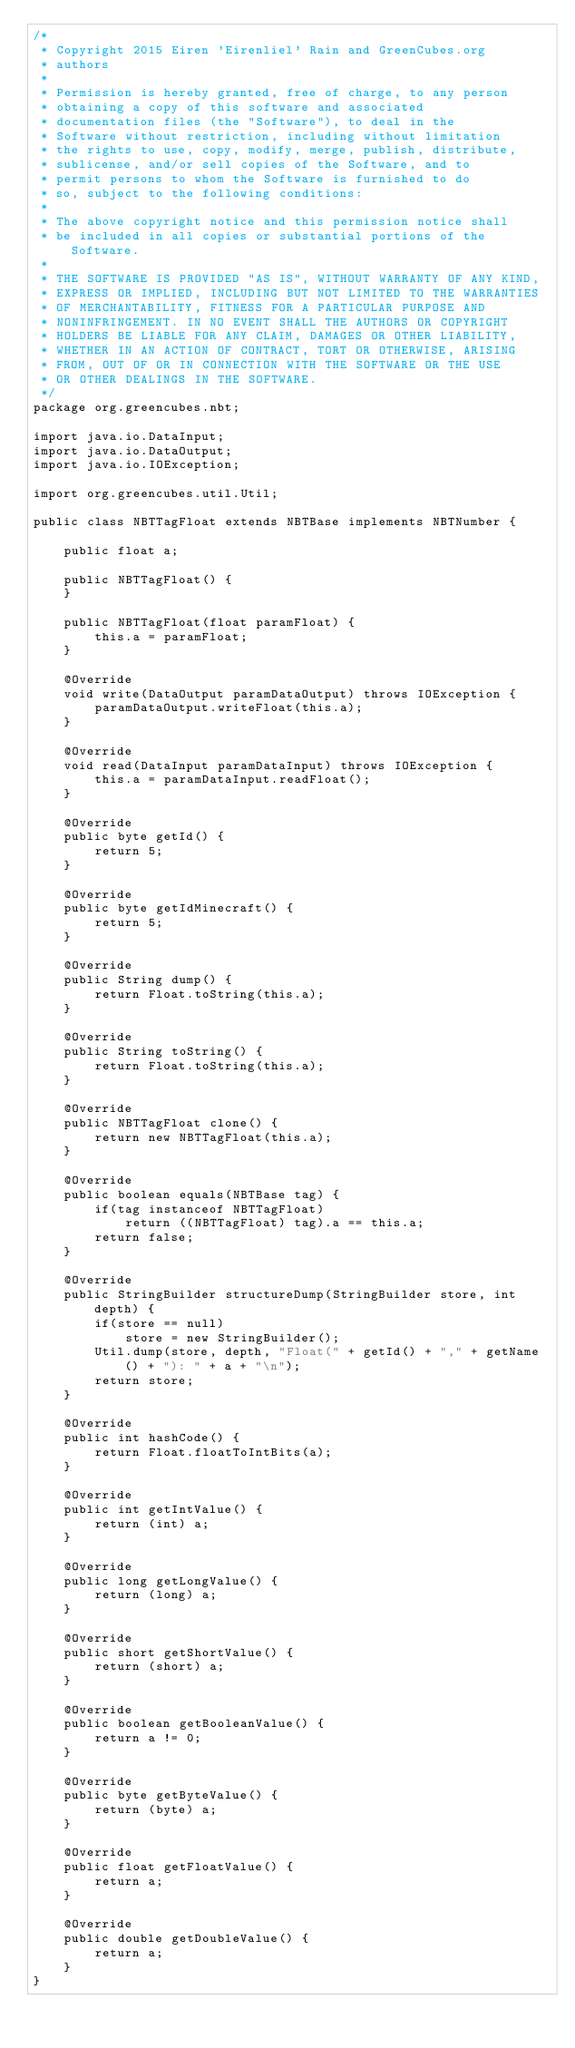<code> <loc_0><loc_0><loc_500><loc_500><_Java_>/*
 * Copyright 2015 Eiren 'Eirenliel' Rain and GreenCubes.org
 * authors
 *
 * Permission is hereby granted, free of charge, to any person
 * obtaining a copy of this software and associated
 * documentation files (the "Software"), to deal in the
 * Software without restriction, including without limitation
 * the rights to use, copy, modify, merge, publish, distribute,
 * sublicense, and/or sell copies of the Software, and to
 * permit persons to whom the Software is furnished to do
 * so, subject to the following conditions:
 *
 * The above copyright notice and this permission notice shall
 * be included in all copies or substantial portions of the Software.
 *
 * THE SOFTWARE IS PROVIDED "AS IS", WITHOUT WARRANTY OF ANY KIND,
 * EXPRESS OR IMPLIED, INCLUDING BUT NOT LIMITED TO THE WARRANTIES
 * OF MERCHANTABILITY, FITNESS FOR A PARTICULAR PURPOSE AND
 * NONINFRINGEMENT. IN NO EVENT SHALL THE AUTHORS OR COPYRIGHT
 * HOLDERS BE LIABLE FOR ANY CLAIM, DAMAGES OR OTHER LIABILITY,
 * WHETHER IN AN ACTION OF CONTRACT, TORT OR OTHERWISE, ARISING
 * FROM, OUT OF OR IN CONNECTION WITH THE SOFTWARE OR THE USE
 * OR OTHER DEALINGS IN THE SOFTWARE.
 */
package org.greencubes.nbt;

import java.io.DataInput;
import java.io.DataOutput;
import java.io.IOException;

import org.greencubes.util.Util;

public class NBTTagFloat extends NBTBase implements NBTNumber {
	
	public float a;
	
	public NBTTagFloat() {
	}
	
	public NBTTagFloat(float paramFloat) {
		this.a = paramFloat;
	}
	
	@Override
	void write(DataOutput paramDataOutput) throws IOException {
		paramDataOutput.writeFloat(this.a);
	}
	
	@Override
	void read(DataInput paramDataInput) throws IOException {
		this.a = paramDataInput.readFloat();
	}
	
	@Override
	public byte getId() {
		return 5;
	}
	
	@Override
	public byte getIdMinecraft() {
		return 5;
	}
	
	@Override
	public String dump() {
		return Float.toString(this.a);
	}
	
	@Override
	public String toString() {
		return Float.toString(this.a);
	}
	
	@Override
	public NBTTagFloat clone() {
		return new NBTTagFloat(this.a);
	}
	
	@Override
	public boolean equals(NBTBase tag) {
		if(tag instanceof NBTTagFloat)
			return ((NBTTagFloat) tag).a == this.a;
		return false;
	}
	
	@Override
	public StringBuilder structureDump(StringBuilder store, int depth) {
		if(store == null)
			store = new StringBuilder();
		Util.dump(store, depth, "Float(" + getId() + "," + getName() + "): " + a + "\n");
		return store;
	}
	
	@Override
	public int hashCode() {
		return Float.floatToIntBits(a);
	}

	@Override
	public int getIntValue() {
		return (int) a;
	}

	@Override
	public long getLongValue() {
		return (long) a;
	}

	@Override
	public short getShortValue() {
		return (short) a;
	}

	@Override
	public boolean getBooleanValue() {
		return a != 0;
	}

	@Override
	public byte getByteValue() {
		return (byte) a;
	}

	@Override
	public float getFloatValue() {
		return a;
	}

	@Override
	public double getDoubleValue() {
		return a;
	}
}
</code> 